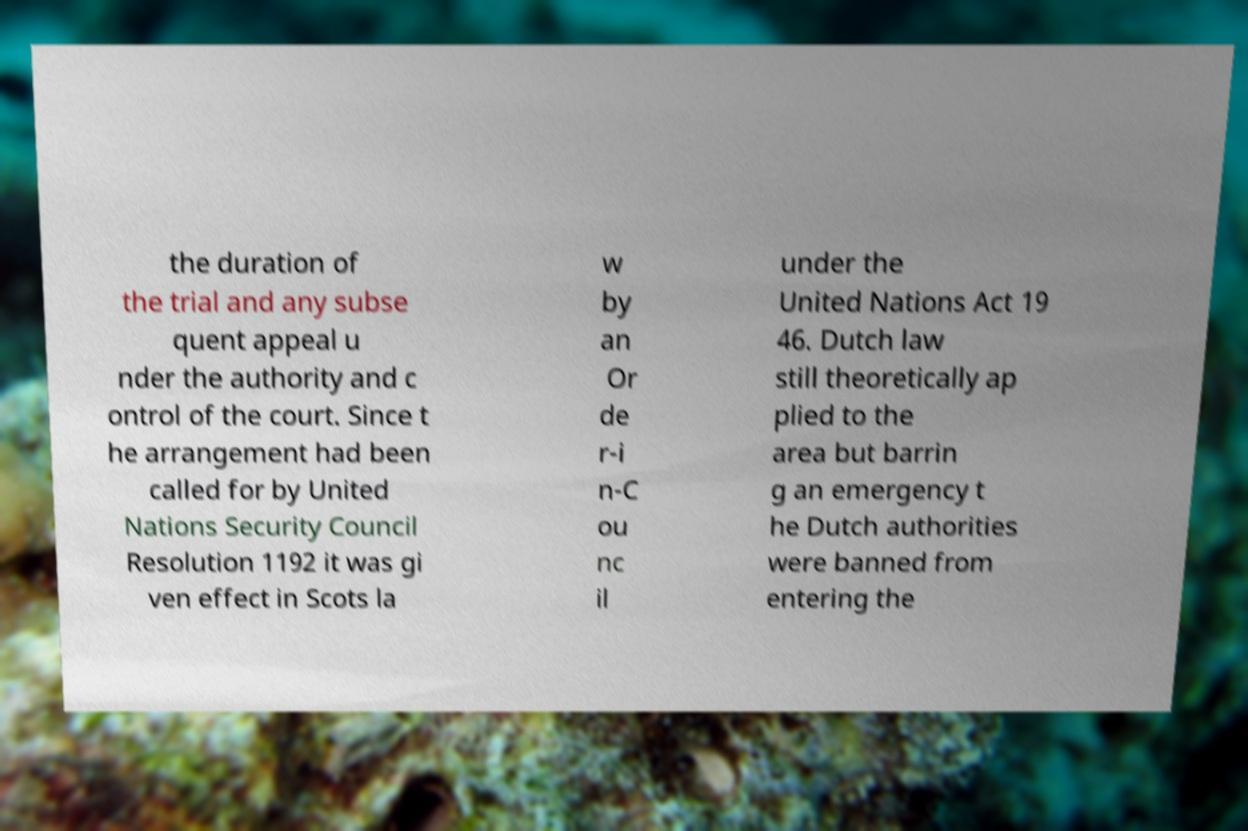There's text embedded in this image that I need extracted. Can you transcribe it verbatim? the duration of the trial and any subse quent appeal u nder the authority and c ontrol of the court. Since t he arrangement had been called for by United Nations Security Council Resolution 1192 it was gi ven effect in Scots la w by an Or de r-i n-C ou nc il under the United Nations Act 19 46. Dutch law still theoretically ap plied to the area but barrin g an emergency t he Dutch authorities were banned from entering the 